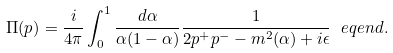Convert formula to latex. <formula><loc_0><loc_0><loc_500><loc_500>\Pi ( p ) = \frac { i } { 4 \pi } \int _ { 0 } ^ { 1 } \frac { d \alpha } { \alpha ( 1 - \alpha ) } \frac { 1 } { 2 p ^ { + } p ^ { - } - m ^ { 2 } ( \alpha ) + i \epsilon } \ e q e n d { . }</formula> 